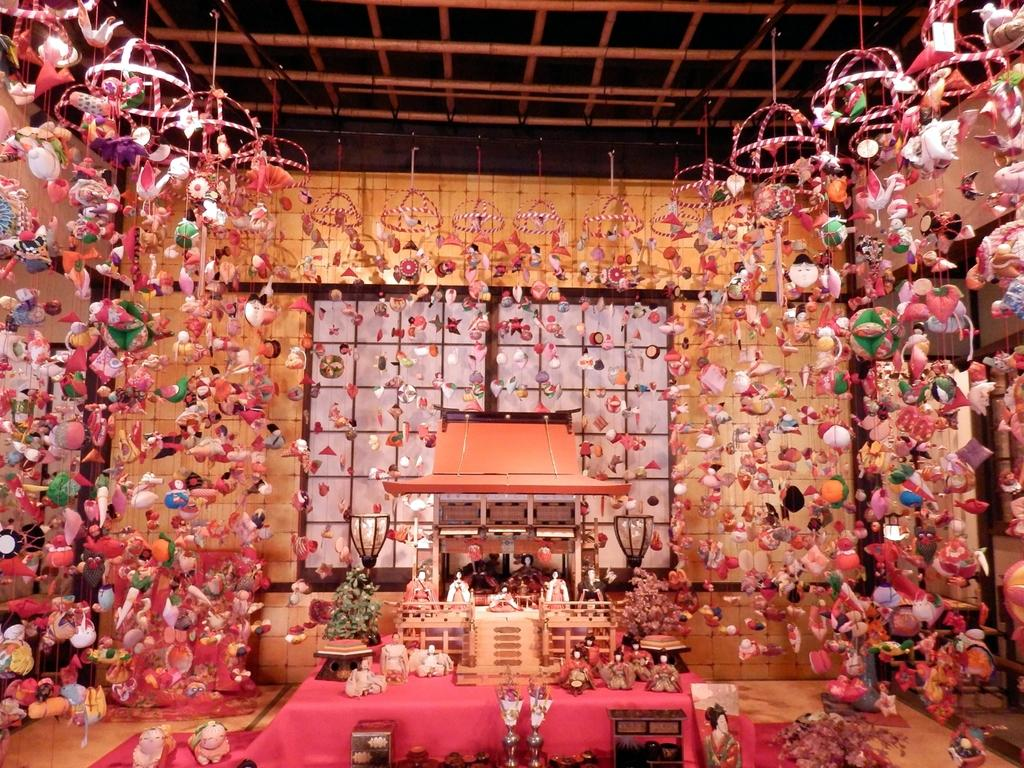What objects can be seen in the image? There are toys in the image. What is located in the center of the image? There is a table in the center of the image. Are there any toys on the table? Yes, toys are present on the table. What can be seen in the background of the image? There is a window and toys hanging in the background of the image. What type of powder is visible on the toys in the image? There is no powder visible on the toys in the image. 